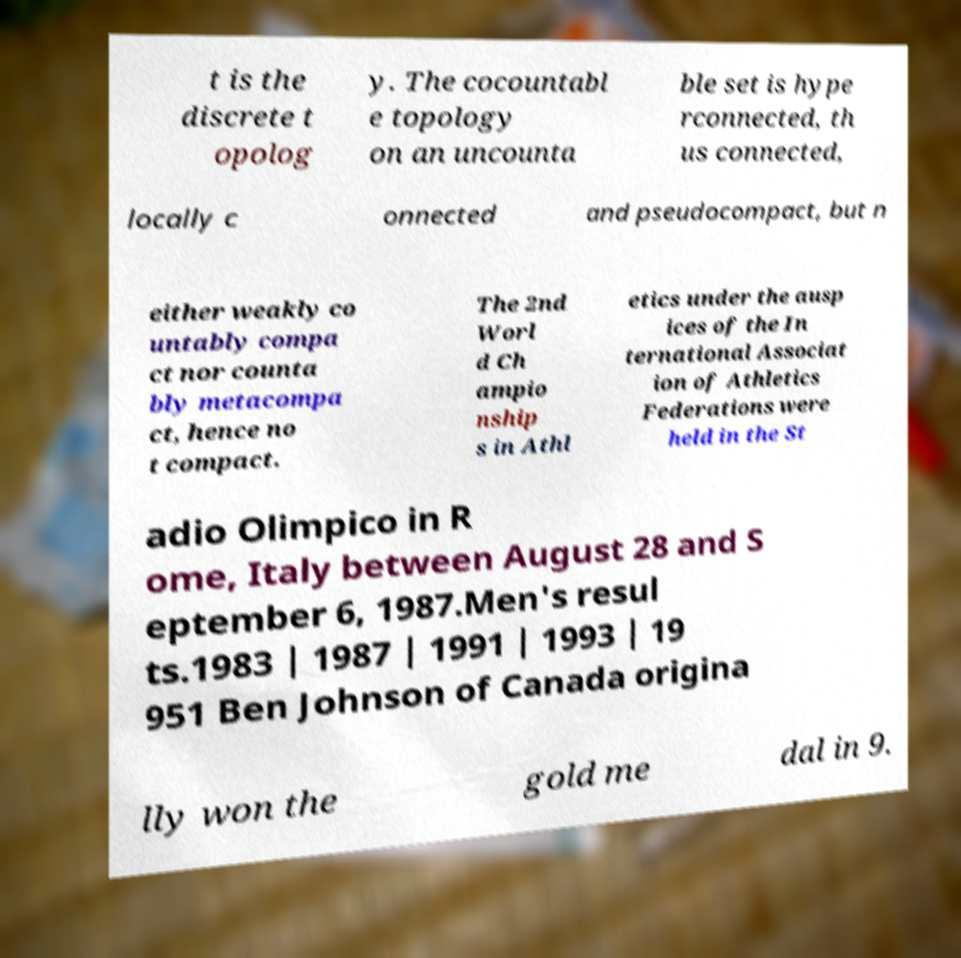Please identify and transcribe the text found in this image. t is the discrete t opolog y. The cocountabl e topology on an uncounta ble set is hype rconnected, th us connected, locally c onnected and pseudocompact, but n either weakly co untably compa ct nor counta bly metacompa ct, hence no t compact. The 2nd Worl d Ch ampio nship s in Athl etics under the ausp ices of the In ternational Associat ion of Athletics Federations were held in the St adio Olimpico in R ome, Italy between August 28 and S eptember 6, 1987.Men's resul ts.1983 | 1987 | 1991 | 1993 | 19 951 Ben Johnson of Canada origina lly won the gold me dal in 9. 